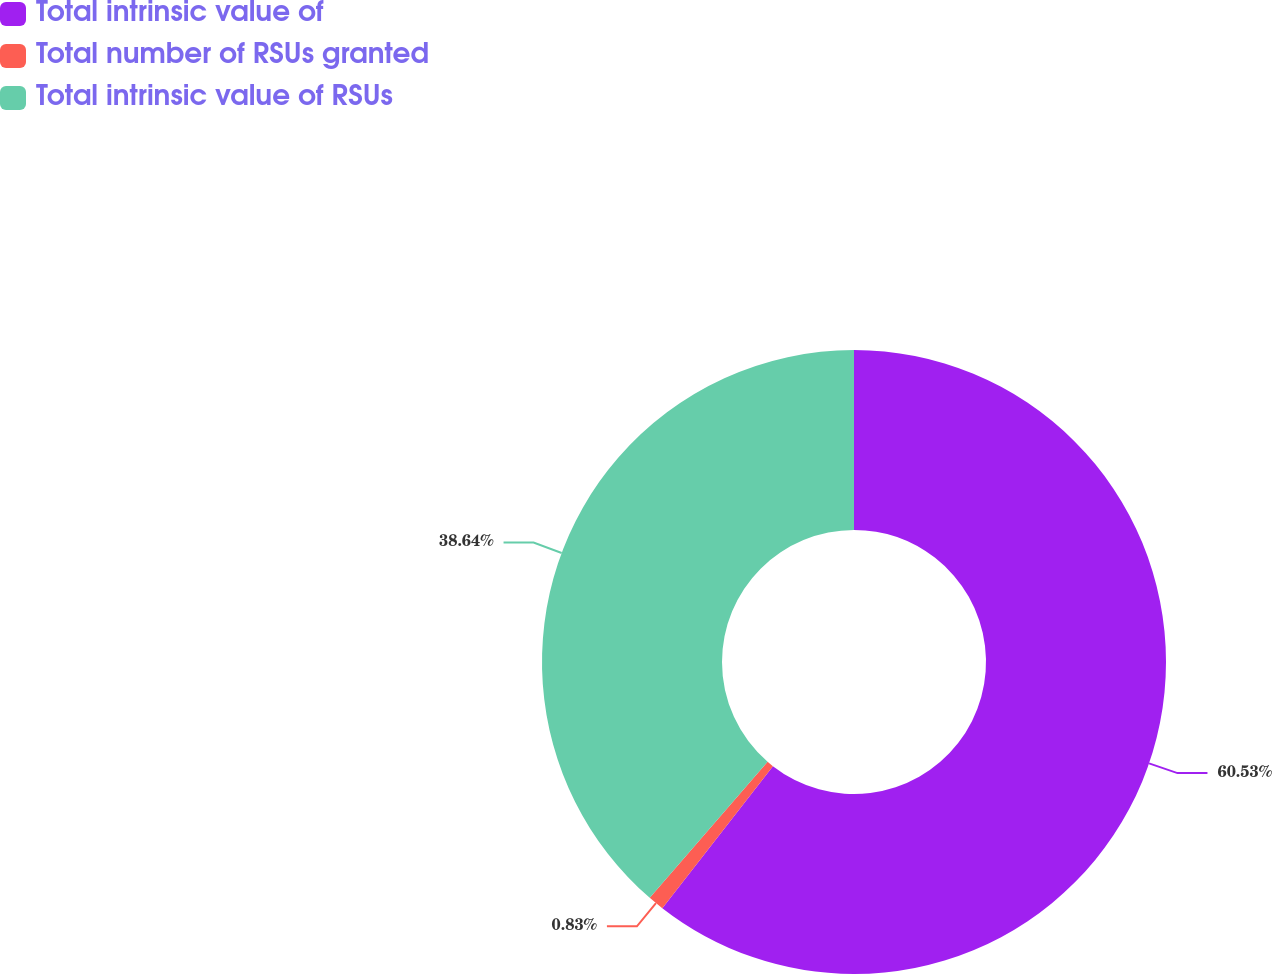Convert chart. <chart><loc_0><loc_0><loc_500><loc_500><pie_chart><fcel>Total intrinsic value of<fcel>Total number of RSUs granted<fcel>Total intrinsic value of RSUs<nl><fcel>60.53%<fcel>0.83%<fcel>38.64%<nl></chart> 